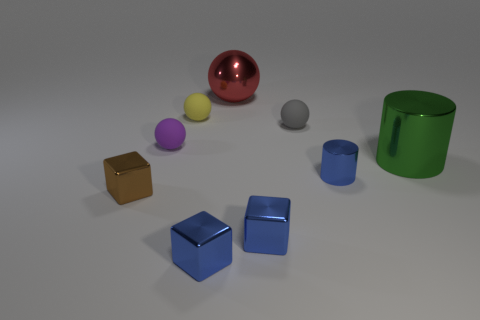What number of small purple matte spheres are in front of the small blue shiny block on the right side of the big shiny thing that is to the left of the big green shiny thing?
Give a very brief answer. 0. What color is the tiny rubber ball that is in front of the small gray ball?
Give a very brief answer. Purple. There is a large metal thing that is behind the purple object; does it have the same color as the tiny metal cylinder?
Offer a very short reply. No. What size is the red thing that is the same shape as the purple thing?
Keep it short and to the point. Large. What material is the big thing to the left of the shiny cylinder that is behind the blue metal object behind the small brown thing?
Your answer should be compact. Metal. Is the number of big red metallic objects that are on the right side of the big green cylinder greater than the number of green objects behind the red sphere?
Your answer should be compact. No. Is the green metallic cylinder the same size as the brown thing?
Your answer should be compact. No. The other large thing that is the same shape as the yellow rubber thing is what color?
Offer a very short reply. Red. How many small things have the same color as the tiny cylinder?
Your answer should be very brief. 2. Are there more big red shiny balls behind the red object than big shiny spheres?
Keep it short and to the point. No. 